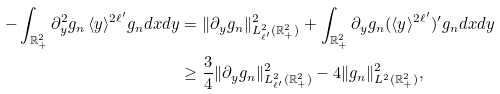<formula> <loc_0><loc_0><loc_500><loc_500>- \int _ { \mathbb { R } ^ { 2 } _ { + } } \partial _ { y } ^ { 2 } g _ { n } \, \langle y \rangle ^ { 2 \ell ^ { \prime } } g _ { n } d x d y & = \| \partial _ { y } g _ { n } \| _ { L ^ { 2 } _ { \ell ^ { \prime } } ( \mathbb { R } ^ { 2 } _ { + } ) } ^ { 2 } + \int _ { \mathbb { R } ^ { 2 } _ { + } } \partial _ { y } g _ { n } ( \langle y \rangle ^ { 2 \ell ^ { \prime } } ) ^ { \prime } g _ { n } d x d y \\ & \geq \frac { 3 } { 4 } \| \partial _ { y } g _ { n } \| _ { L ^ { 2 } _ { \ell ^ { \prime } } ( \mathbb { R } ^ { 2 } _ { + } ) } ^ { 2 } - 4 \| g _ { n } \| _ { L ^ { 2 } ( \mathbb { R } ^ { 2 } _ { + } ) } ^ { 2 } ,</formula> 